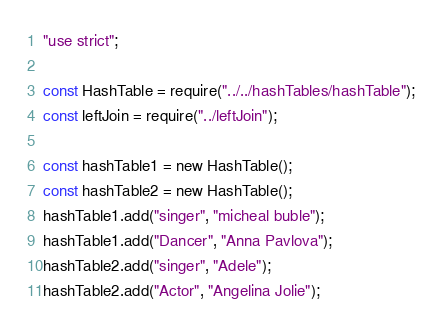<code> <loc_0><loc_0><loc_500><loc_500><_JavaScript_>"use strict";

const HashTable = require("../../hashTables/hashTable");
const leftJoin = require("../leftJoin");

const hashTable1 = new HashTable();
const hashTable2 = new HashTable();
hashTable1.add("singer", "micheal buble");
hashTable1.add("Dancer", "Anna Pavlova");
hashTable2.add("singer", "Adele");
hashTable2.add("Actor", "Angelina Jolie");
</code> 